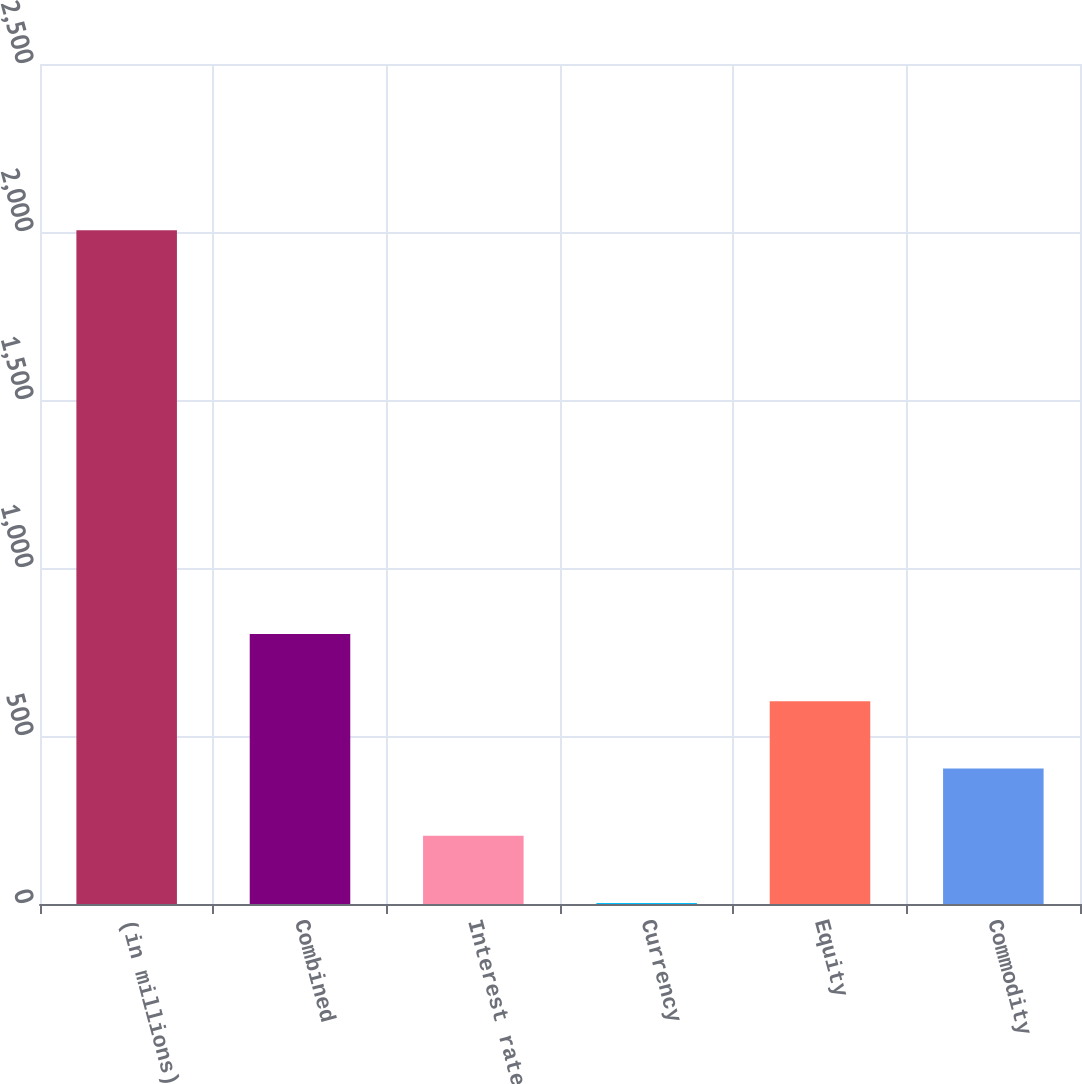<chart> <loc_0><loc_0><loc_500><loc_500><bar_chart><fcel>(in millions)<fcel>Combined<fcel>Interest rate<fcel>Currency<fcel>Equity<fcel>Commodity<nl><fcel>2005<fcel>803.8<fcel>203.2<fcel>3<fcel>603.6<fcel>403.4<nl></chart> 